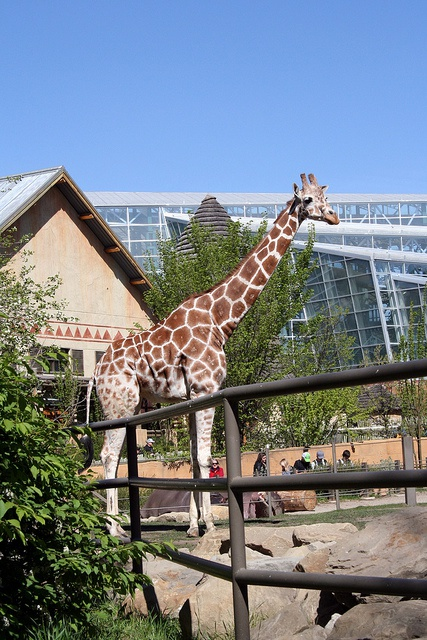Describe the objects in this image and their specific colors. I can see giraffe in lightblue, lightgray, brown, black, and darkgray tones, people in lightblue, black, gray, darkgray, and maroon tones, people in lightblue, gray, darkgray, black, and lightgray tones, people in lightblue, brown, maroon, and black tones, and people in lightblue, black, gray, and darkgray tones in this image. 